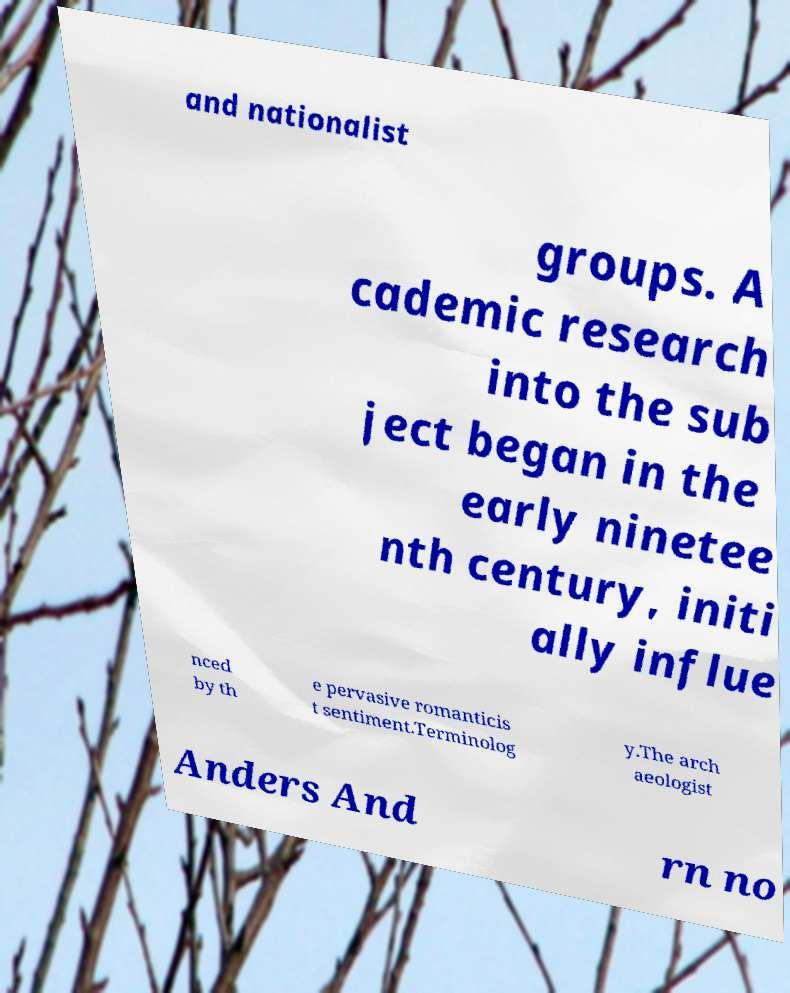There's text embedded in this image that I need extracted. Can you transcribe it verbatim? and nationalist groups. A cademic research into the sub ject began in the early ninetee nth century, initi ally influe nced by th e pervasive romanticis t sentiment.Terminolog y.The arch aeologist Anders And rn no 